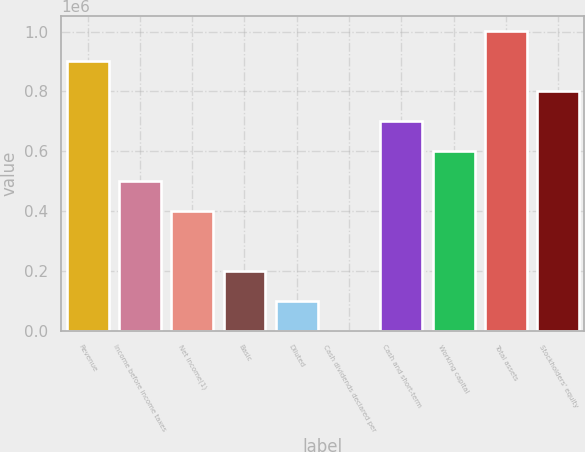Convert chart. <chart><loc_0><loc_0><loc_500><loc_500><bar_chart><fcel>Revenue<fcel>Income before income taxes<fcel>Net income(1)<fcel>Basic<fcel>Diluted<fcel>Cash dividends declared per<fcel>Cash and short-term<fcel>Working capital<fcel>Total assets<fcel>Stockholders' equity<nl><fcel>901254<fcel>500697<fcel>400557<fcel>200279<fcel>100139<fcel>0.1<fcel>700975<fcel>600836<fcel>1.00139e+06<fcel>801114<nl></chart> 